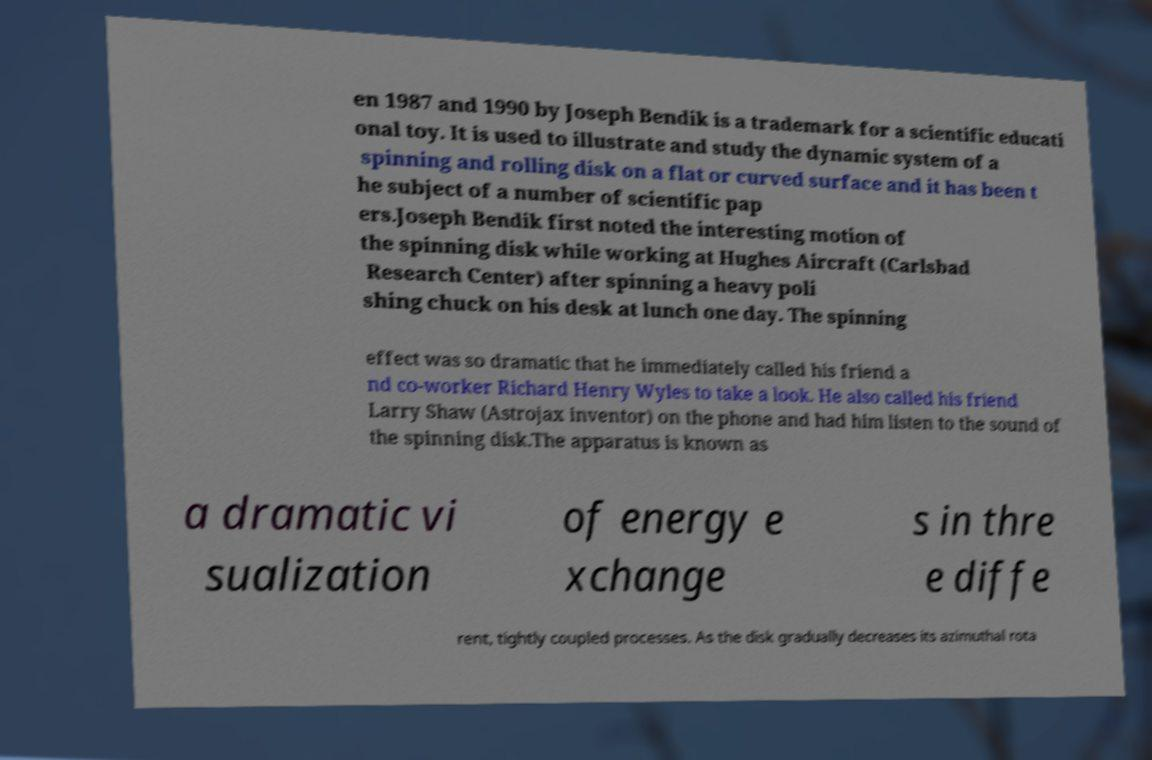Please identify and transcribe the text found in this image. en 1987 and 1990 by Joseph Bendik is a trademark for a scientific educati onal toy. It is used to illustrate and study the dynamic system of a spinning and rolling disk on a flat or curved surface and it has been t he subject of a number of scientific pap ers.Joseph Bendik first noted the interesting motion of the spinning disk while working at Hughes Aircraft (Carlsbad Research Center) after spinning a heavy poli shing chuck on his desk at lunch one day. The spinning effect was so dramatic that he immediately called his friend a nd co-worker Richard Henry Wyles to take a look. He also called his friend Larry Shaw (Astrojax inventor) on the phone and had him listen to the sound of the spinning disk.The apparatus is known as a dramatic vi sualization of energy e xchange s in thre e diffe rent, tightly coupled processes. As the disk gradually decreases its azimuthal rota 